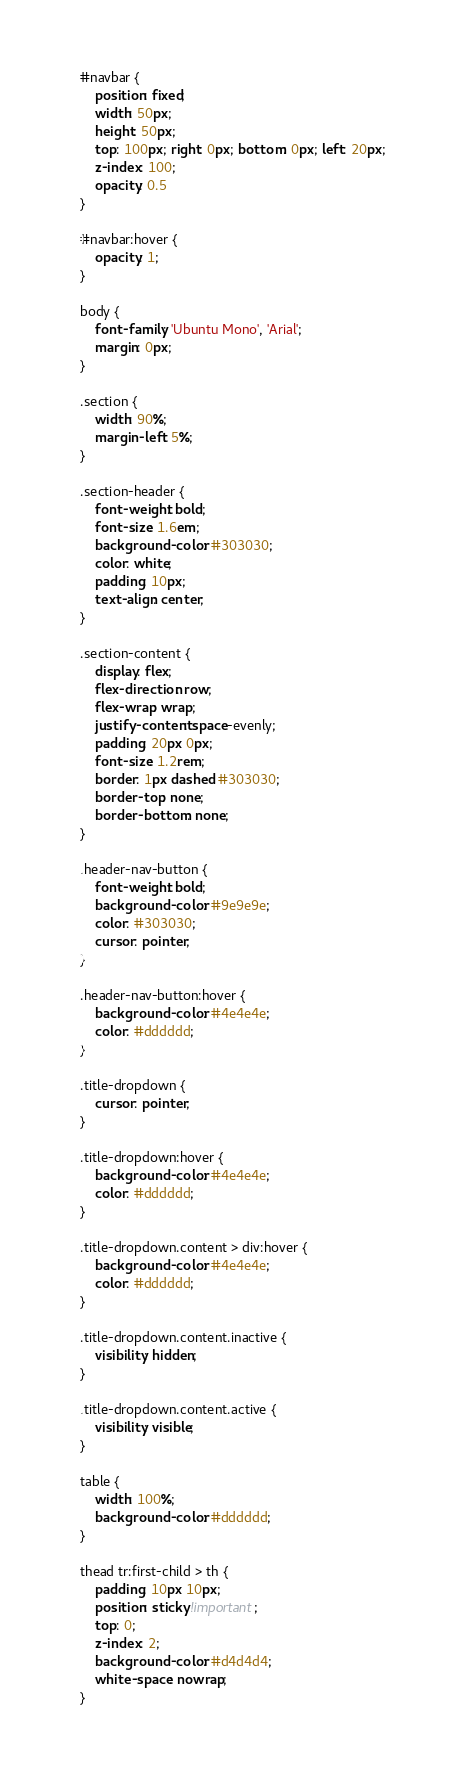Convert code to text. <code><loc_0><loc_0><loc_500><loc_500><_CSS_>#navbar {
    position: fixed;
    width: 50px;
    height: 50px;
    top: 100px; right: 0px; bottom: 0px; left: 20px;
    z-index: 100;
    opacity: 0.5
}

#navbar:hover {
    opacity: 1;
}

body {
    font-family: 'Ubuntu Mono', 'Arial';
    margin: 0px;
}

.section {
    width: 90%;
    margin-left: 5%;
}

.section-header {
    font-weight: bold;
    font-size: 1.6em;
    background-color: #303030;
    color: white;
    padding: 10px;
    text-align: center;
}

.section-content {
    display: flex;
    flex-direction: row;
    flex-wrap: wrap;
    justify-content: space-evenly;
    padding: 20px 0px;
    font-size: 1.2rem;
    border: 1px dashed #303030;
    border-top: none;
    border-bottom: none;
}

.header-nav-button {
    font-weight: bold;
    background-color: #9e9e9e;
    color: #303030;
    cursor: pointer;
}

.header-nav-button:hover {
    background-color: #4e4e4e;
    color: #dddddd;
}

.title-dropdown {
    cursor: pointer;
}

.title-dropdown:hover {
    background-color: #4e4e4e;
    color: #dddddd;
}

.title-dropdown.content > div:hover {
    background-color: #4e4e4e;
    color: #dddddd;
}

.title-dropdown.content.inactive {
    visibility: hidden;
}

.title-dropdown.content.active {
    visibility: visible;
}

table { 
    width: 100%;
    background-color: #dddddd;
}

thead tr:first-child > th {
    padding: 10px 10px;
    position: sticky !important;
    top: 0;
    z-index: 2;
    background-color: #d4d4d4;
    white-space: nowrap;
}
</code> 